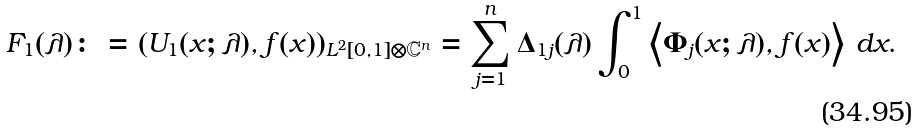<formula> <loc_0><loc_0><loc_500><loc_500>F _ { 1 } ( \lambda ) \colon = ( U _ { 1 } ( x ; \lambda ) , f ( x ) ) _ { L ^ { 2 } [ 0 , 1 ] \otimes \mathbb { C } ^ { n } } = \sum _ { j = 1 } ^ { n } \Delta _ { 1 j } ( \lambda ) \int _ { 0 } ^ { 1 } \left \langle \Phi _ { j } ( x ; \lambda ) , f ( x ) \right \rangle \, d x .</formula> 